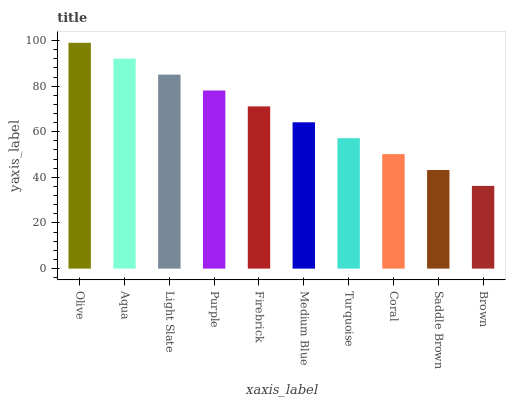Is Brown the minimum?
Answer yes or no. Yes. Is Olive the maximum?
Answer yes or no. Yes. Is Aqua the minimum?
Answer yes or no. No. Is Aqua the maximum?
Answer yes or no. No. Is Olive greater than Aqua?
Answer yes or no. Yes. Is Aqua less than Olive?
Answer yes or no. Yes. Is Aqua greater than Olive?
Answer yes or no. No. Is Olive less than Aqua?
Answer yes or no. No. Is Firebrick the high median?
Answer yes or no. Yes. Is Medium Blue the low median?
Answer yes or no. Yes. Is Purple the high median?
Answer yes or no. No. Is Saddle Brown the low median?
Answer yes or no. No. 